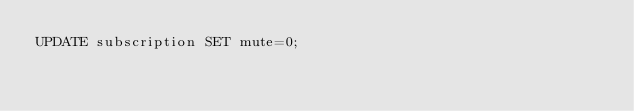Convert code to text. <code><loc_0><loc_0><loc_500><loc_500><_SQL_>UPDATE subscription SET mute=0;
</code> 